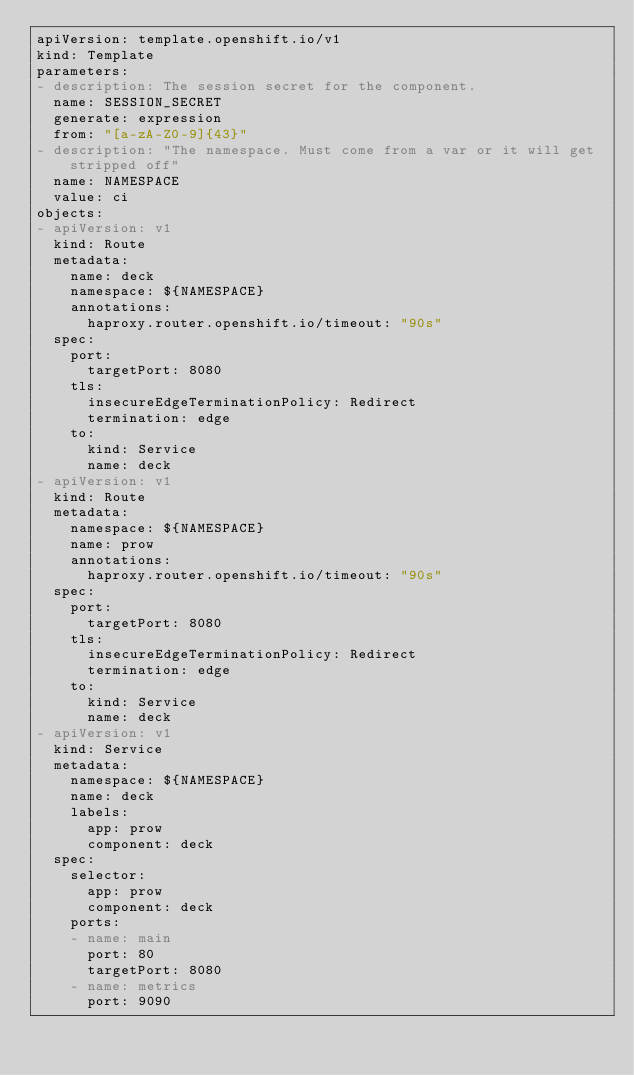<code> <loc_0><loc_0><loc_500><loc_500><_YAML_>apiVersion: template.openshift.io/v1
kind: Template
parameters:
- description: The session secret for the component.
  name: SESSION_SECRET
  generate: expression
  from: "[a-zA-Z0-9]{43}"
- description: "The namespace. Must come from a var or it will get stripped off"
  name: NAMESPACE
  value: ci
objects:
- apiVersion: v1
  kind: Route
  metadata:
    name: deck
    namespace: ${NAMESPACE}
    annotations:
      haproxy.router.openshift.io/timeout: "90s"
  spec:
    port:
      targetPort: 8080
    tls:
      insecureEdgeTerminationPolicy: Redirect
      termination: edge
    to:
      kind: Service
      name: deck
- apiVersion: v1
  kind: Route
  metadata:
    namespace: ${NAMESPACE}
    name: prow
    annotations:
      haproxy.router.openshift.io/timeout: "90s"
  spec:
    port:
      targetPort: 8080
    tls:
      insecureEdgeTerminationPolicy: Redirect
      termination: edge
    to:
      kind: Service
      name: deck
- apiVersion: v1
  kind: Service
  metadata:
    namespace: ${NAMESPACE}
    name: deck
    labels:
      app: prow
      component: deck
  spec:
    selector:
      app: prow
      component: deck
    ports:
    - name: main
      port: 80
      targetPort: 8080
    - name: metrics
      port: 9090</code> 